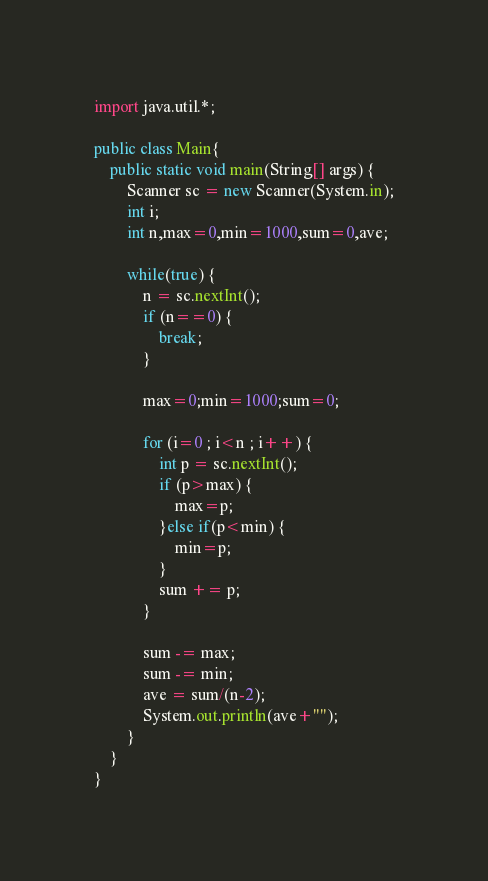<code> <loc_0><loc_0><loc_500><loc_500><_Java_>import java.util.*;

public class Main{
	public static void main(String[] args) {
		Scanner sc = new Scanner(System.in);
		int i;
		int n,max=0,min=1000,sum=0,ave;
		
		while(true) {
			n = sc.nextInt();
			if (n==0) {
				break;
			}
			
			max=0;min=1000;sum=0;
			
			for (i=0 ; i<n ; i++) {
				int p = sc.nextInt();
				if (p>max) {
					max=p;
				}else if(p<min) {
					min=p;
				}
				sum += p;
			}
			
			sum -= max;
			sum -= min;
			ave = sum/(n-2);
			System.out.println(ave+"");
		}
	}
}
</code> 